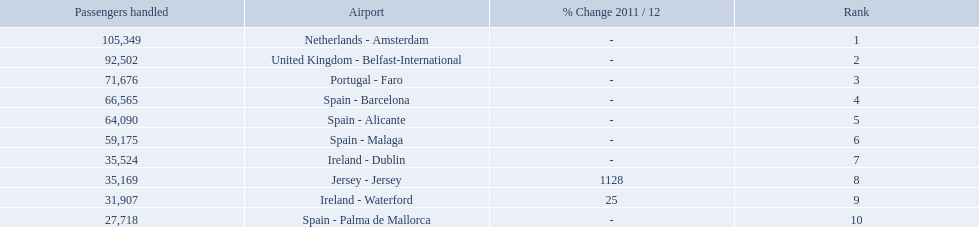Which airports are in europe? Netherlands - Amsterdam, United Kingdom - Belfast-International, Portugal - Faro, Spain - Barcelona, Spain - Alicante, Spain - Malaga, Ireland - Dublin, Ireland - Waterford, Spain - Palma de Mallorca. Which one is from portugal? Portugal - Faro. What are the 10 busiest routes to and from london southend airport? Netherlands - Amsterdam, United Kingdom - Belfast-International, Portugal - Faro, Spain - Barcelona, Spain - Alicante, Spain - Malaga, Ireland - Dublin, Jersey - Jersey, Ireland - Waterford, Spain - Palma de Mallorca. Of these, which airport is in portugal? Portugal - Faro. What are all of the routes out of the london southend airport? Netherlands - Amsterdam, United Kingdom - Belfast-International, Portugal - Faro, Spain - Barcelona, Spain - Alicante, Spain - Malaga, Ireland - Dublin, Jersey - Jersey, Ireland - Waterford, Spain - Palma de Mallorca. How many passengers have traveled to each destination? 105,349, 92,502, 71,676, 66,565, 64,090, 59,175, 35,524, 35,169, 31,907, 27,718. And which destination has been the most popular to passengers? Netherlands - Amsterdam. Which airports had passengers going through london southend airport? Netherlands - Amsterdam, United Kingdom - Belfast-International, Portugal - Faro, Spain - Barcelona, Spain - Alicante, Spain - Malaga, Ireland - Dublin, Jersey - Jersey, Ireland - Waterford, Spain - Palma de Mallorca. Of those airports, which airport had the least amount of passengers going through london southend airport? Spain - Palma de Mallorca. 